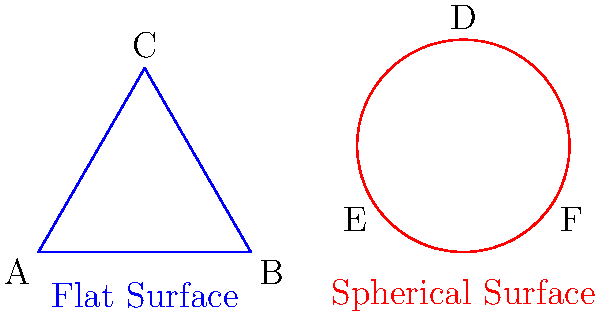In the diagram above, we see two triangles: one on a flat surface (ABC) and one on a spherical surface (DEF). How does the sum of the interior angles of triangle DEF on the spherical surface compare to the sum of the interior angles of triangle ABC on the flat surface? Explain the geometric principle behind this difference. To understand the difference between the sum of interior angles in triangles on flat and spherical surfaces, let's follow these steps:

1. Flat surface triangle (ABC):
   - In Euclidean geometry, the sum of interior angles of any triangle is always 180°.
   - This is a fundamental property of flat (planar) geometry.

2. Spherical surface triangle (DEF):
   - Spherical geometry is a non-Euclidean geometry where lines are great circles on the surface of a sphere.
   - In spherical geometry, the sum of interior angles of a triangle is always greater than 180°.

3. The principle behind the difference:
   - On a sphere, the surface is curved, which affects the behavior of lines and angles.
   - As the sides of a spherical triangle are arcs of great circles, they "bulge" outward compared to straight lines on a flat surface.
   - This bulging causes the angles to be larger than they would be on a flat surface.

4. Mathematical expression:
   - For a spherical triangle, the sum of interior angles is given by the formula:
     $$ \text{Sum of angles} = 180° + A $$
   - Where $A$ is the area of the triangle on the sphere's surface, expressed in steradians (solid angle).

5. Excess angle:
   - The difference between the sum of angles in a spherical triangle and 180° is called the "spherical excess."
   - This excess is directly proportional to the area of the triangle on the sphere's surface.

6. Implications:
   - As the size of the spherical triangle increases, so does the sum of its interior angles.
   - For very small triangles on a sphere, the sum of angles approaches 180°, as the surface becomes nearly flat at small scales.

In conclusion, the sum of interior angles in triangle DEF on the spherical surface is always greater than the sum of interior angles in triangle ABC on the flat surface, due to the curvature of the spherical surface affecting the geometry of the triangle.
Answer: Greater than 180° 